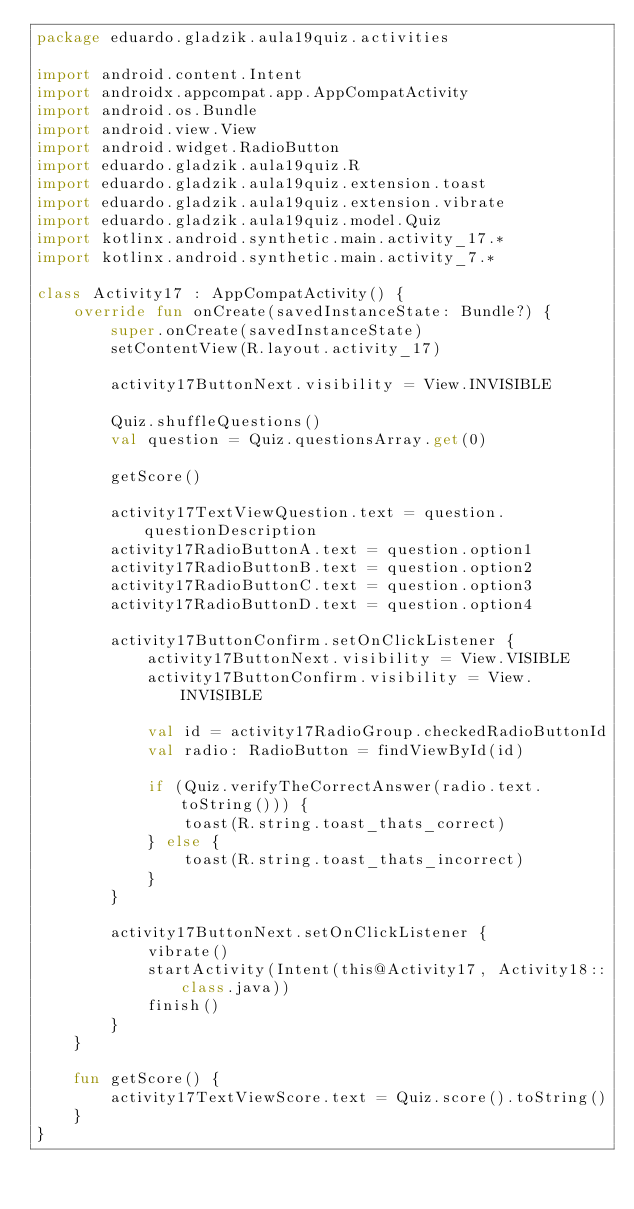Convert code to text. <code><loc_0><loc_0><loc_500><loc_500><_Kotlin_>package eduardo.gladzik.aula19quiz.activities

import android.content.Intent
import androidx.appcompat.app.AppCompatActivity
import android.os.Bundle
import android.view.View
import android.widget.RadioButton
import eduardo.gladzik.aula19quiz.R
import eduardo.gladzik.aula19quiz.extension.toast
import eduardo.gladzik.aula19quiz.extension.vibrate
import eduardo.gladzik.aula19quiz.model.Quiz
import kotlinx.android.synthetic.main.activity_17.*
import kotlinx.android.synthetic.main.activity_7.*

class Activity17 : AppCompatActivity() {
    override fun onCreate(savedInstanceState: Bundle?) {
        super.onCreate(savedInstanceState)
        setContentView(R.layout.activity_17)

        activity17ButtonNext.visibility = View.INVISIBLE

        Quiz.shuffleQuestions()
        val question = Quiz.questionsArray.get(0)

        getScore()

        activity17TextViewQuestion.text = question.questionDescription
        activity17RadioButtonA.text = question.option1
        activity17RadioButtonB.text = question.option2
        activity17RadioButtonC.text = question.option3
        activity17RadioButtonD.text = question.option4

        activity17ButtonConfirm.setOnClickListener {
            activity17ButtonNext.visibility = View.VISIBLE
            activity17ButtonConfirm.visibility = View.INVISIBLE

            val id = activity17RadioGroup.checkedRadioButtonId
            val radio: RadioButton = findViewById(id)

            if (Quiz.verifyTheCorrectAnswer(radio.text.toString())) {
                toast(R.string.toast_thats_correct)
            } else {
                toast(R.string.toast_thats_incorrect)
            }
        }

        activity17ButtonNext.setOnClickListener {
            vibrate()
            startActivity(Intent(this@Activity17, Activity18::class.java))
            finish()
        }
    }

    fun getScore() {
        activity17TextViewScore.text = Quiz.score().toString()
    }
}</code> 